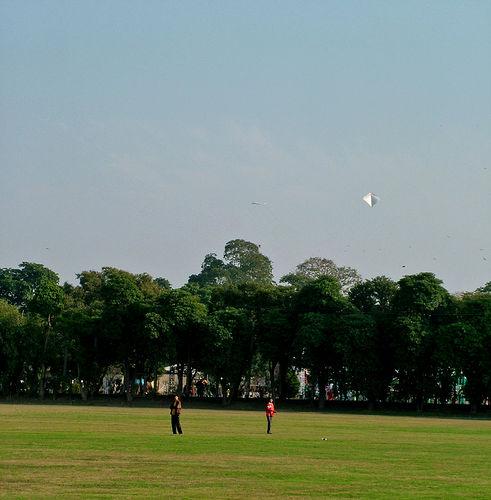What are they looking at?
Give a very brief answer. Kite. Does this look like a sunny day?
Answer briefly. Yes. What is the bright object in the sky?
Quick response, please. Kite. What color shirt is the kid wearing?
Short answer required. Red. How many people are on the ground?
Quick response, please. 2. Is this an opened field?
Quick response, please. Yes. What kind of day is this photo?
Give a very brief answer. Sunny. How many people are in the image?
Answer briefly. 2. 